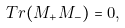Convert formula to latex. <formula><loc_0><loc_0><loc_500><loc_500>T r ( M _ { + } M _ { - } ) = 0 ,</formula> 